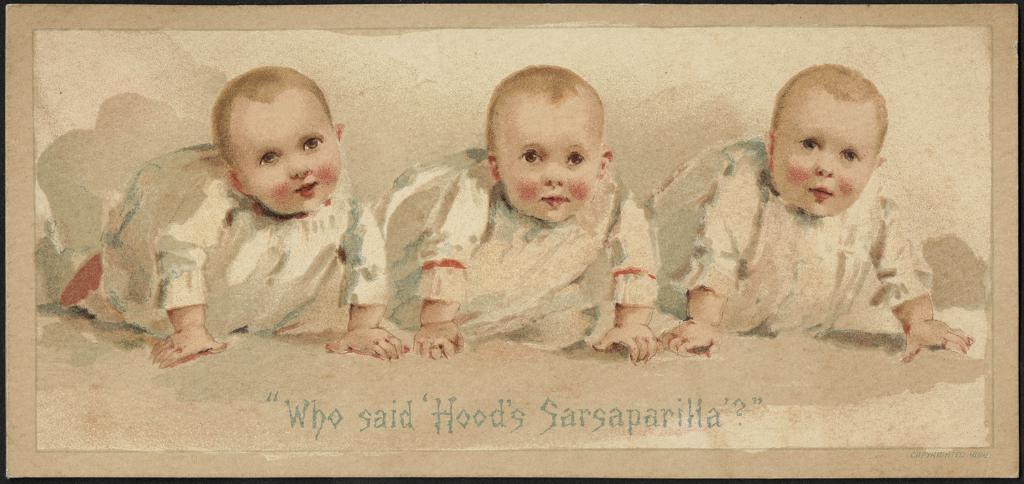What is the main subject of the image? The image is a picture of a painting. What is depicted in the painting? There are three babies depicted in the painting. Are there any words present in the painting? Yes, there are words present in the painting. What type of voice can be heard coming from the babies in the painting? There is no voice present in the painting, as it is a static image and not a video or audio recording. What type of offer is being made by the babies in the painting? There is no offer being made by the babies in the painting, as it is a static image and not a depiction of a real-life scenario. 